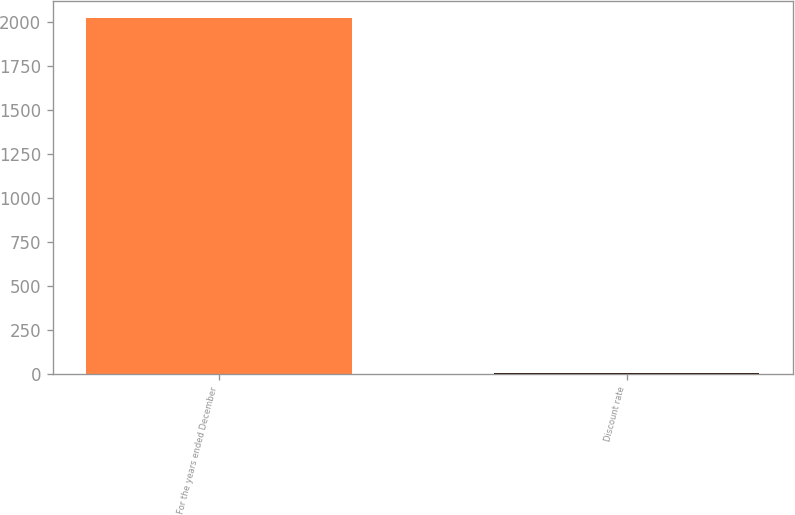<chart> <loc_0><loc_0><loc_500><loc_500><bar_chart><fcel>For the years ended December<fcel>Discount rate<nl><fcel>2018<fcel>3.4<nl></chart> 